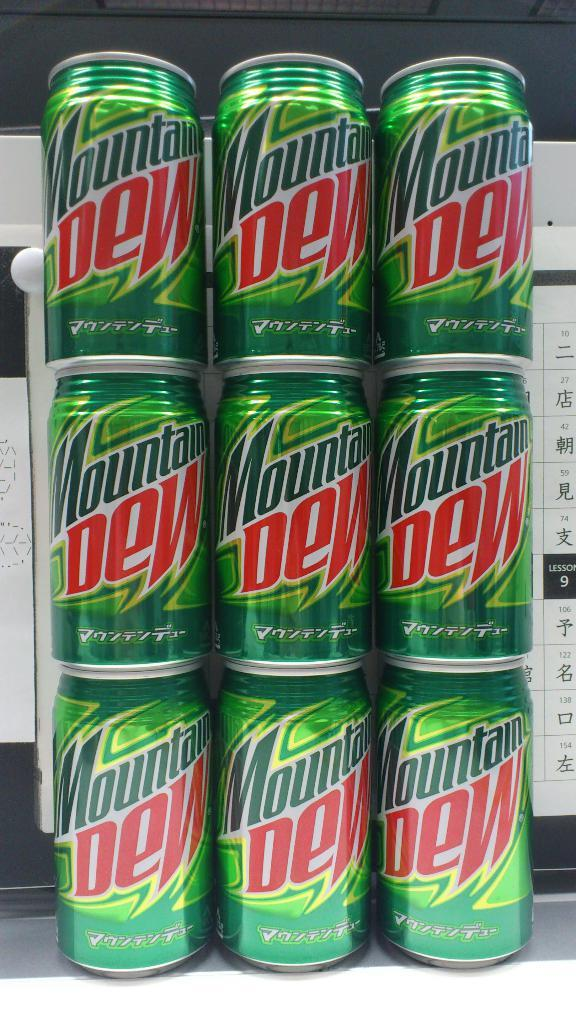Provide a one-sentence caption for the provided image. A stack of Mountain Dew cans that is three cans high and three wide. 